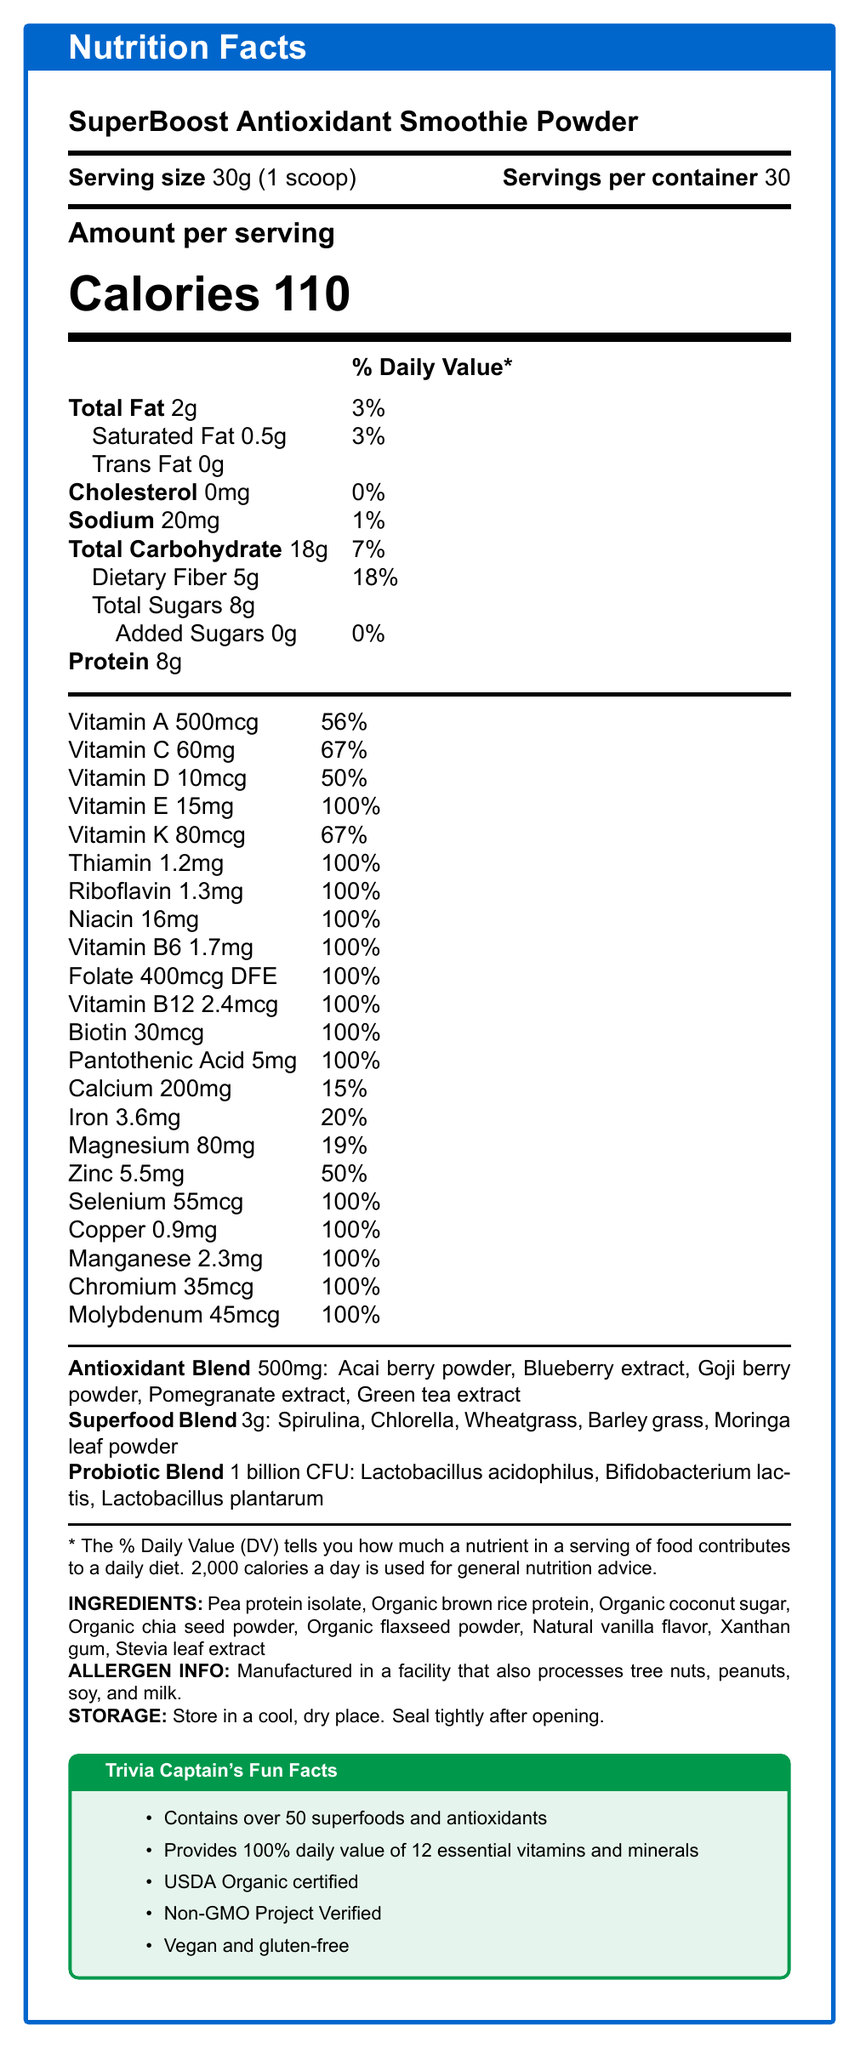What is the serving size? The document states that the serving size is 30g, equal to 1 scoop.
Answer: 30g (1 scoop) How many calories are there per serving? The document lists 110 calories per serving under the "Amount per serving" section.
Answer: 110 What percentage of the daily value of Vitamin C does one serving provide? According to the vitamin and mineral breakdown, Vitamin C is provided at 67% of the daily value.
Answer: 67% Which ingredient is NOT part of the antioxidant blend? A. Acai berry powder B. Blueberry extract C. Spirulina D. Pomegranate extract The antioxidant blend includes Acai berry powder, Blueberry extract, Goji berry powder, Pomegranate extract, and Green tea extract. Spirulina is part of the superfood blend.
Answer: C. Spirulina How much dietary fiber is included per serving? Dietary fiber amounts to 5 grams per serving, as shown in the nutrient section.
Answer: 5g What is the daily percentage value of Zinc provided by one serving? Zinc provides 50% of the daily value as listed in the vitamins and minerals section.
Answer: 50% Which vitamin/mineral offers 100% of the daily value for a wide range of selections? A. Vitamin A B. Vitamin E C. Calcium D. Magnesium Vitamin E alongside several other listed vitamins and minerals provides 100% of the daily value.
Answer: B. Vitamin E What is the allergen information mentioned on the label? The document includes allergen information stating it is manufactured in a facility that also processes tree nuts, peanuts, soy, and milk.
Answer: Manufactured in a facility that also processes tree nuts, peanuts, soy, and milk. Does this product contain any added sugars? The document clearly indicates that the total added sugars amount to 0g, meaning no added sugars are present.
Answer: No How many servings are contained in one container? The serving information at the beginning of the document states there are 30 servings per container.
Answer: 30 Which blend has the largest weight per serving? A. Antioxidant Blend B. Superfood Blend C. Probiotic Blend The Superfood Blend is 3g per serving, Antioxidant Blend is 500mg, and Probiotic Blend is 1 billion CFU.
Answer: B. Superfood Blend Is this product certified organic? Under the "Trivia Captain's Fun Facts" section, the document states that the product is USDA Organic certified.
Answer: Yes What strains of probiotics are included in the Probiotic Blend? The Probiotic Blend lists these three probiotic strains.
Answer: Lactobacillus acidophilus, Bifidobacterium lactis, Lactobacillus plantarum Summarize the main content of the document. The document is structured to give a comprehensive overview of the nutritional content and additional details such as ingredients, blends, certifications, and fun facts about the "SuperBoost Antioxidant Smoothie Powder."
Answer: The document provides detailed nutritional information for the "SuperBoost Antioxidant Smoothie Powder," including serving size, calories, fats, carbohydrates, proteins, and vitamins/minerals. It includes specific blends for antioxidants, superfoods, and probiotics. Additionally, it highlights fun facts and certifications, allergens, and storage instructions. What are the storage instructions for this product? The storage instructions are clearly listed at the end of the document, advising to store in a cool, dry place and to seal tightly after opening.
Answer: Store in a cool, dry place. Seal tightly after opening. How many grams of protein are there per serving? The document lists the protein content per serving as 8 grams.
Answer: 8g What is the purpose of Xanthan gum in the ingredient list? The document lists the ingredients but does not explain the specific purpose of Xanthan gum within the product.
Answer: Cannot be determined Does the product provide the daily value of Vitamin D? According to the vitamin and mineral breakdown, Vitamin D provides 50% of the daily value per serving.
Answer: No, it provides 50% of the daily value. 